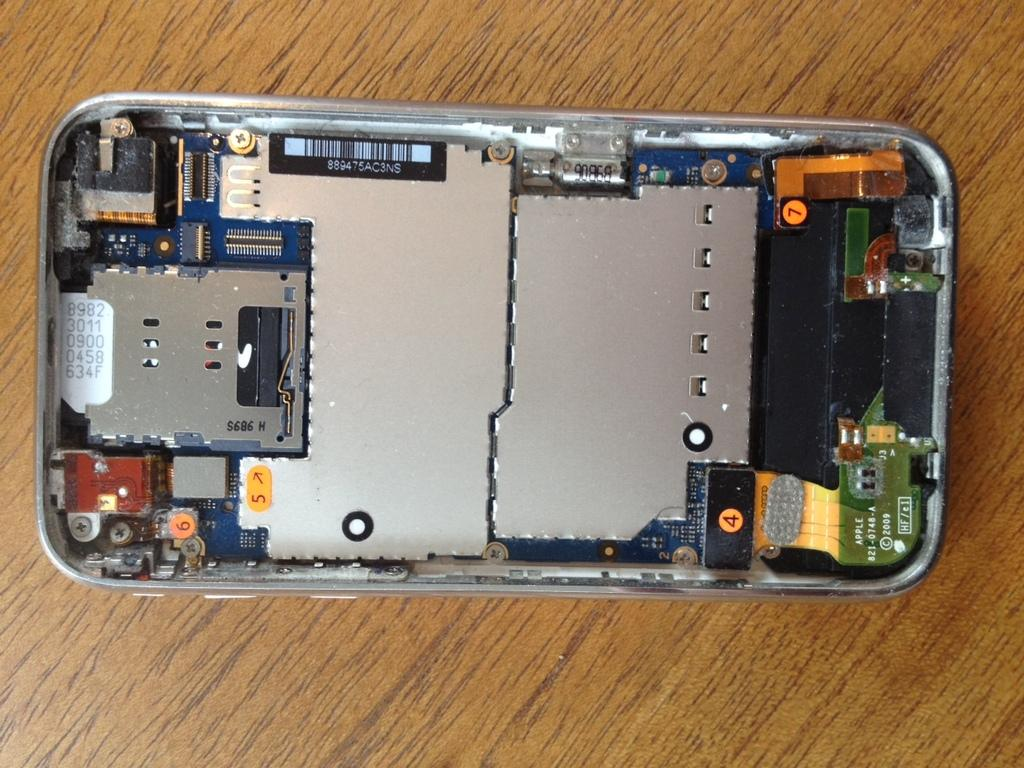<image>
Provide a brief description of the given image. the inside of a silver phone that says 's686 H' on one of the sides 